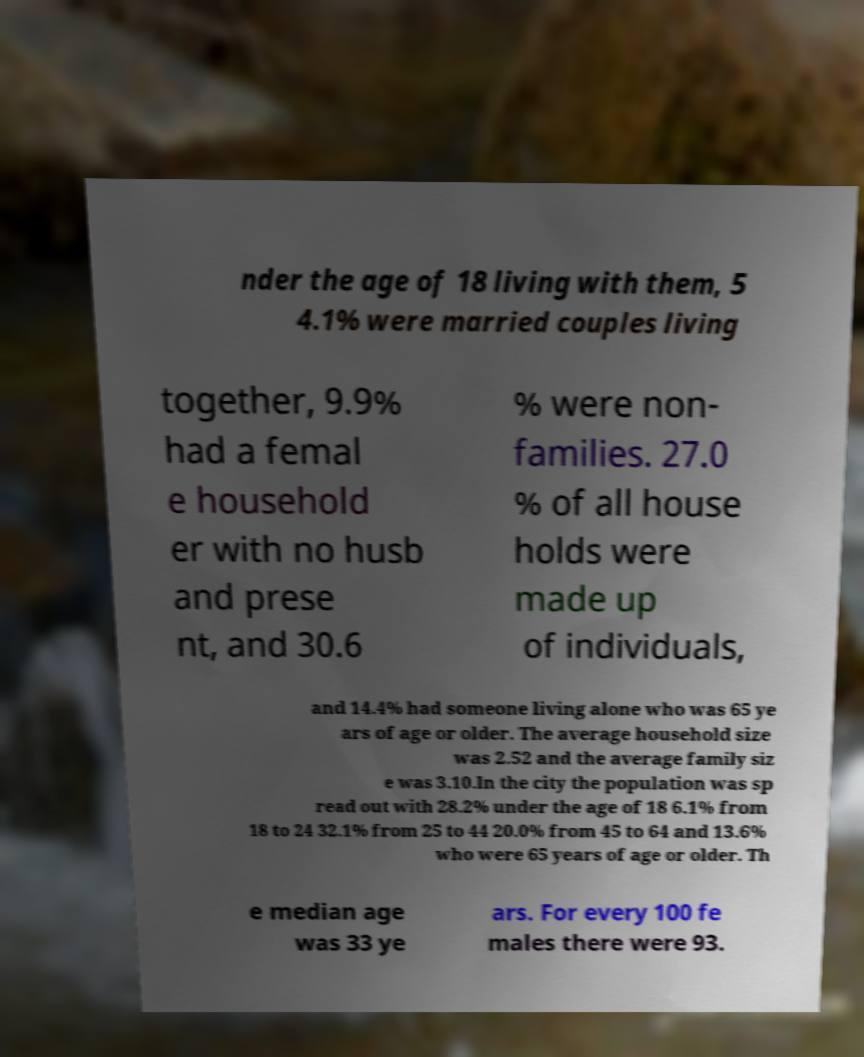Could you extract and type out the text from this image? nder the age of 18 living with them, 5 4.1% were married couples living together, 9.9% had a femal e household er with no husb and prese nt, and 30.6 % were non- families. 27.0 % of all house holds were made up of individuals, and 14.4% had someone living alone who was 65 ye ars of age or older. The average household size was 2.52 and the average family siz e was 3.10.In the city the population was sp read out with 28.2% under the age of 18 6.1% from 18 to 24 32.1% from 25 to 44 20.0% from 45 to 64 and 13.6% who were 65 years of age or older. Th e median age was 33 ye ars. For every 100 fe males there were 93. 